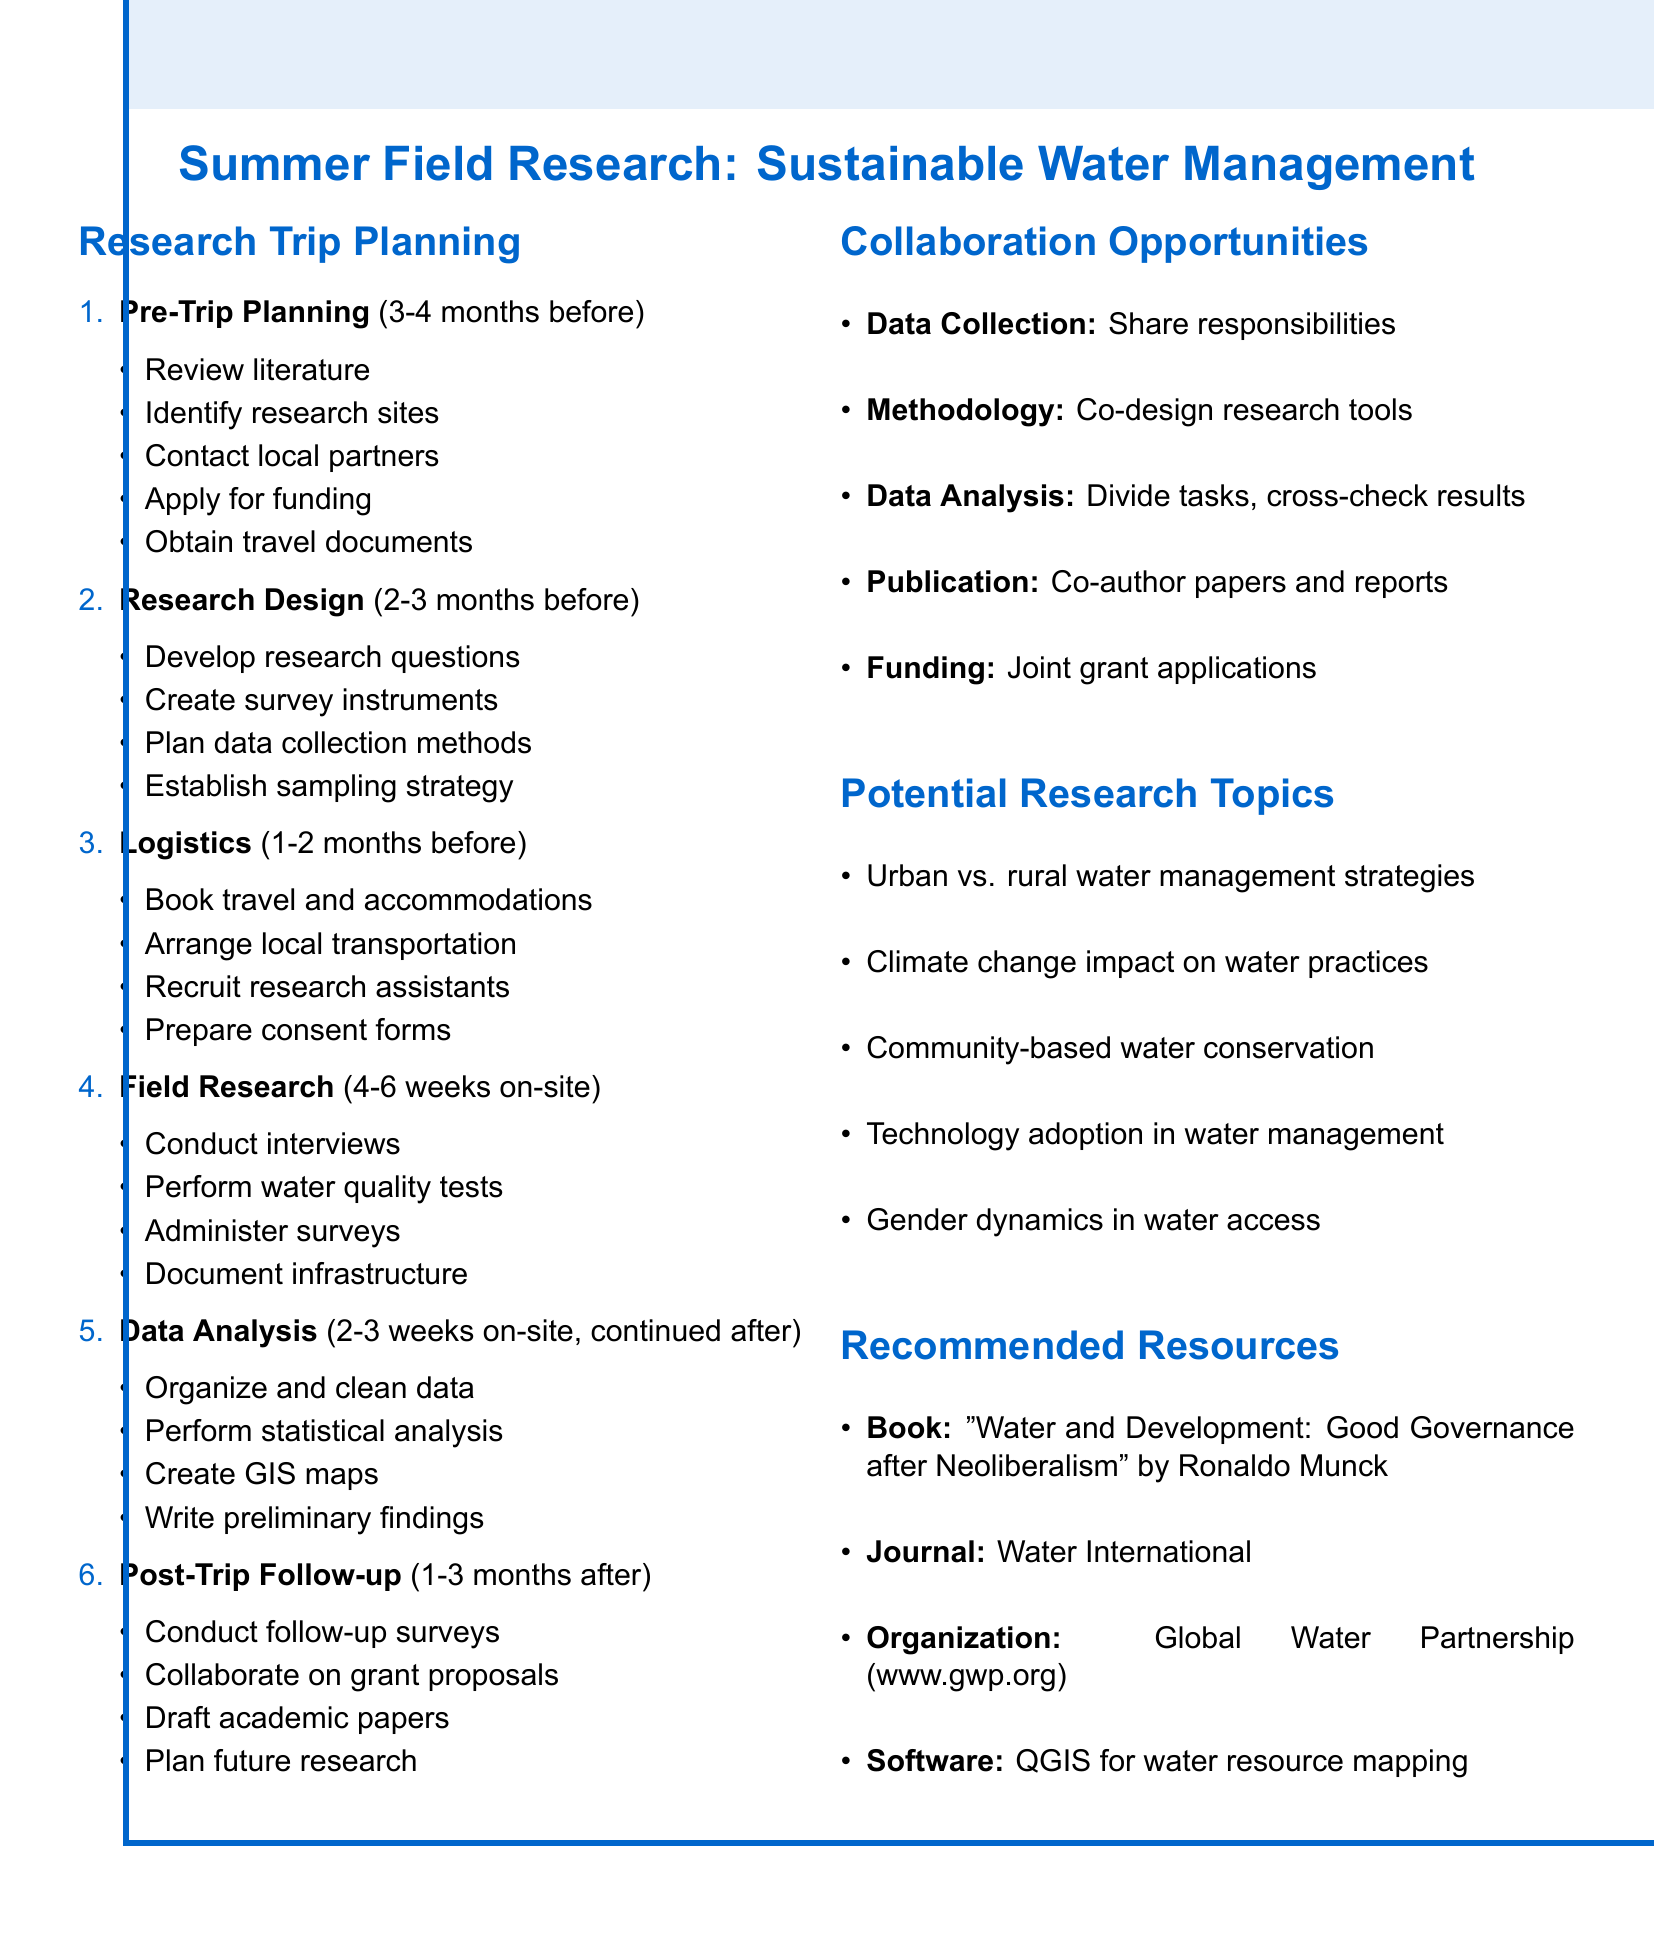what is the duration for the Pre-Trip Planning phase? The duration for the Pre-Trip Planning phase is stated in the document as 3-4 months before departure.
Answer: 3-4 months which organization is mentioned as a potential partner for research? The document lists organizations and includes Global Water Partnership as a potential partner for research.
Answer: Global Water Partnership what are the two types of analysis mentioned in the Data Analysis and Reporting phase? The document specifies statistical analysis and creating GIS maps as the two types of analysis in the Data Analysis and Reporting phase.
Answer: statistical analysis and GIS maps how long does the Field Research phase take? The document indicates that the Field Research phase lasts for 4-6 weeks on-site.
Answer: 4-6 weeks what is one benefit of co-designing research instruments? The document explains that co-designing research instruments leads to improved validity and reliability of research tools.
Answer: Improved validity and reliability what is a recommended software for mapping water resources? The document recommends QGIS as essential software for mapping water resources.
Answer: QGIS how many months after the trip does the Post-Trip Follow-up phase occur? The document states the Post-Trip Follow-up phase takes place 1-3 months after return.
Answer: 1-3 months what is one research topic mentioned that addresses gender issues? One potential research topic mentioned in the document is gender dynamics in water access and management roles.
Answer: Gender dynamics in water access and management roles 